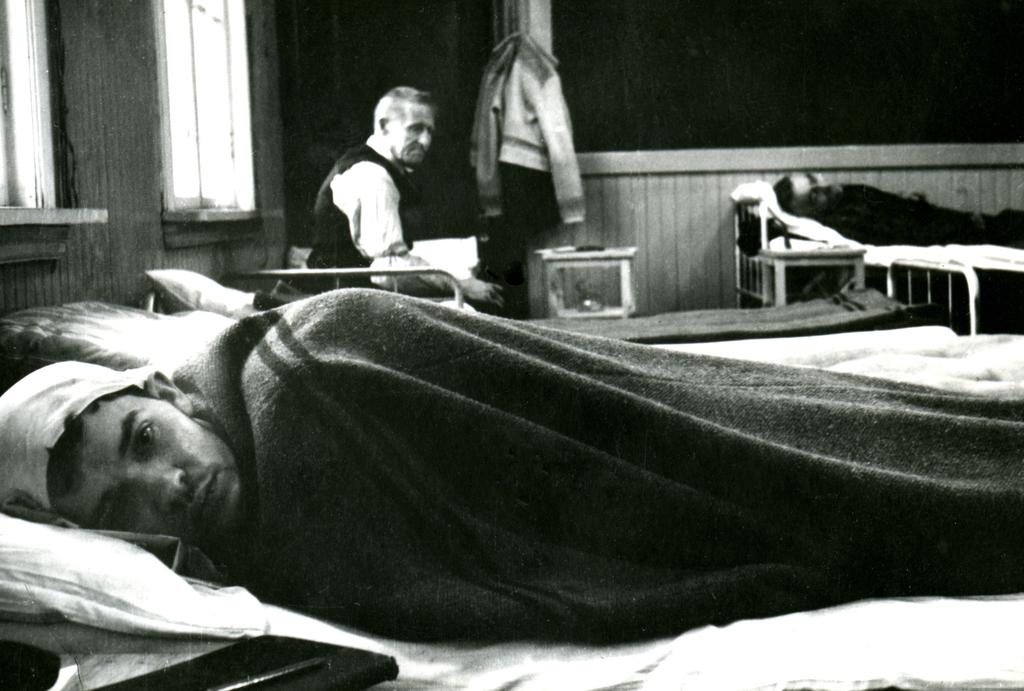How many people are in the image? There are three persons in the image. What are the positions of the persons in the image? Two of the persons are lying on the bed, and one person is sitting. What can be seen in the background of the image? There are windows, clothes, and a wall in the background of the image. What year is depicted in the image? The image does not depict a specific year; it is a snapshot of a moment in time. What part of society is represented in the image? The image does not represent a specific part of society; it simply shows three people in a room with some background elements. 